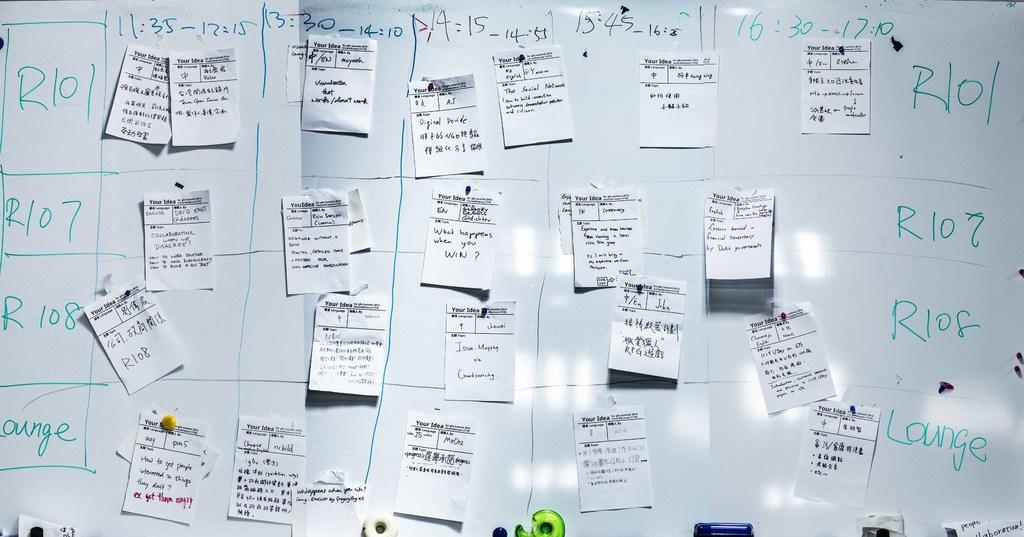<image>
Render a clear and concise summary of the photo. A whiteboard is divided into sections with various labels that start with R and has paper notes taped on it. 